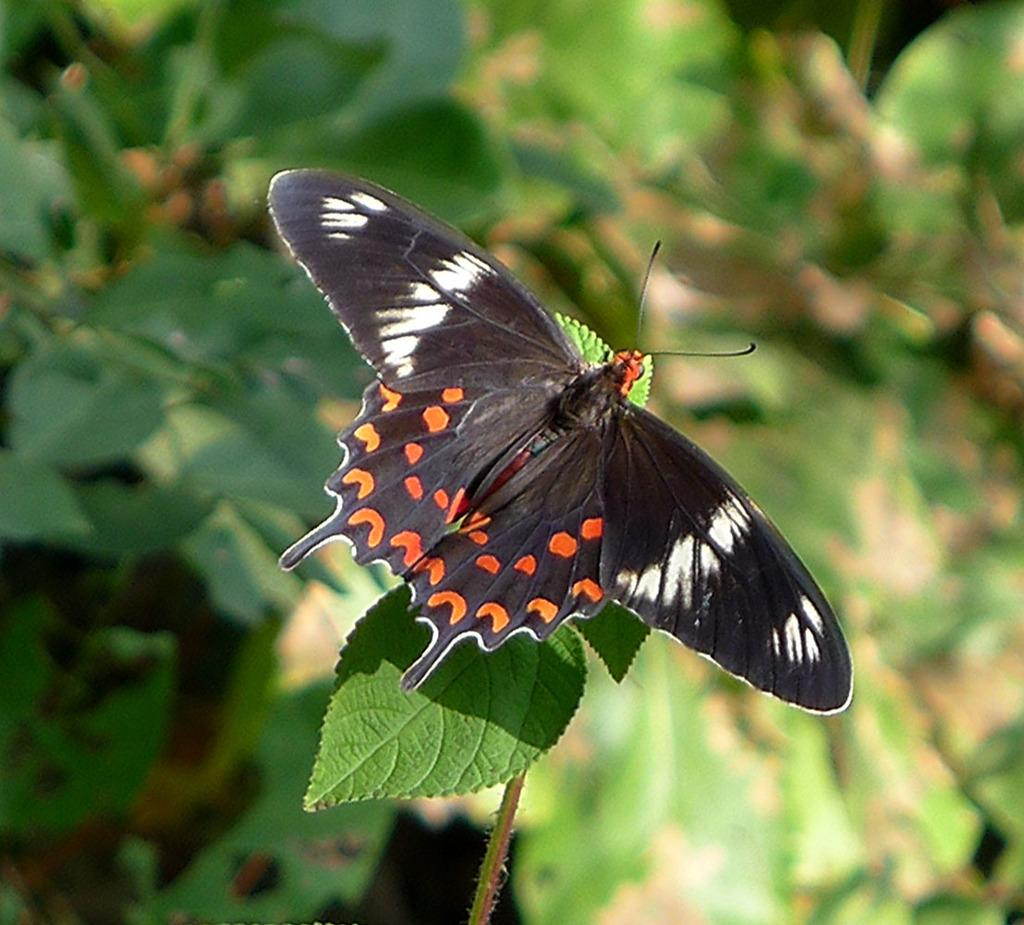What is the main subject of the image? There is a butterfly in the image. Can you describe the colors of the butterfly? The butterfly has orange, black, and white colors. Where is the butterfly located in the image? The butterfly is on a leaf. What color is the leaf? The leaf is green. What can be seen in the background of the image? There are plants in the background of the image. What color are the plants in the background? The plants in the background are green. What type of pencil can be seen in the image? There is no pencil present in the image. How does the root of the plant in the image look like? There is no root visible in the image; only the butterfly, leaf, and plants in the background are present. 